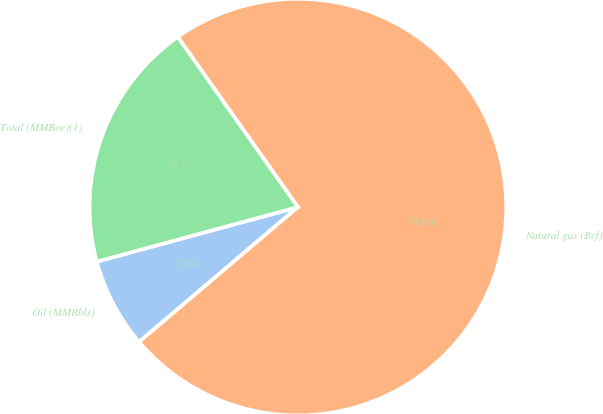<chart> <loc_0><loc_0><loc_500><loc_500><pie_chart><fcel>Oil (MMBbls)<fcel>Natural gas (Bcf)<fcel>Total (MMBoe)(1)<nl><fcel>6.99%<fcel>73.58%<fcel>19.43%<nl></chart> 